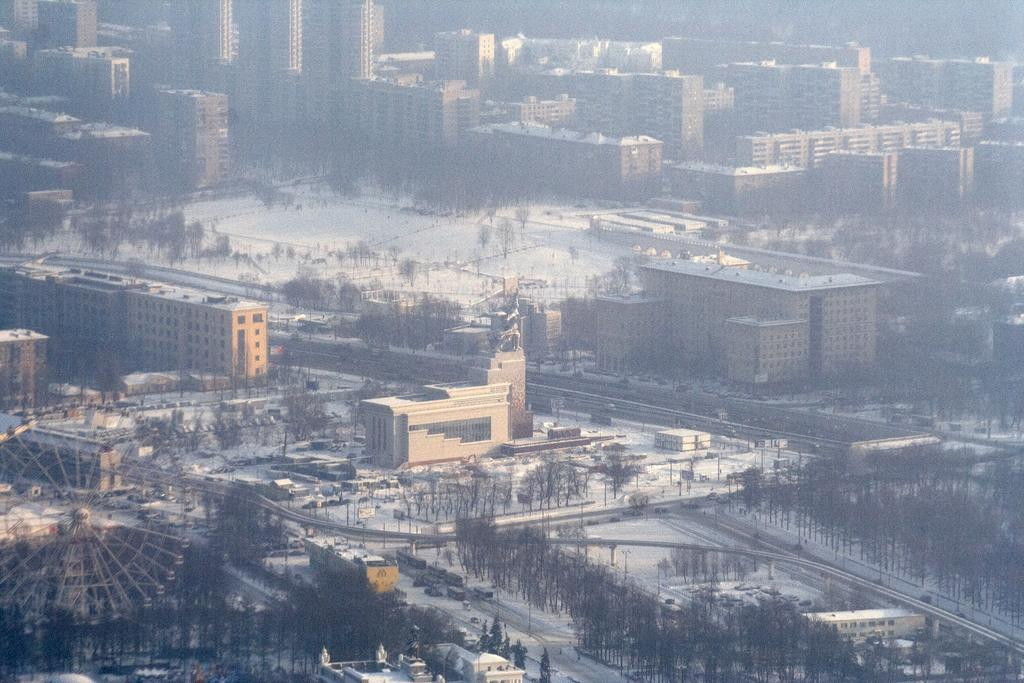What is located on the left side of the image? There is a giant wheel on the left side of the image. What can be seen in the center of the image? There is a statue in the center of the image. What is the condition of the surface in the image? There is snow on the surface in the image. What type of vegetation is visible in the image? Trees are visible in the image. What type of structures are present in the image? Buildings are present in the image. What type of vehicles can be seen in the image? Cars are visible in the image. What type of fowl can be seen nesting in the statue in the image? There is no fowl nesting in the statue in the image. What is the need for the station in the image? There is no station present in the image. 